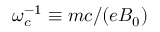Convert formula to latex. <formula><loc_0><loc_0><loc_500><loc_500>\omega _ { c } ^ { - 1 } \equiv m c / ( e B _ { 0 } )</formula> 